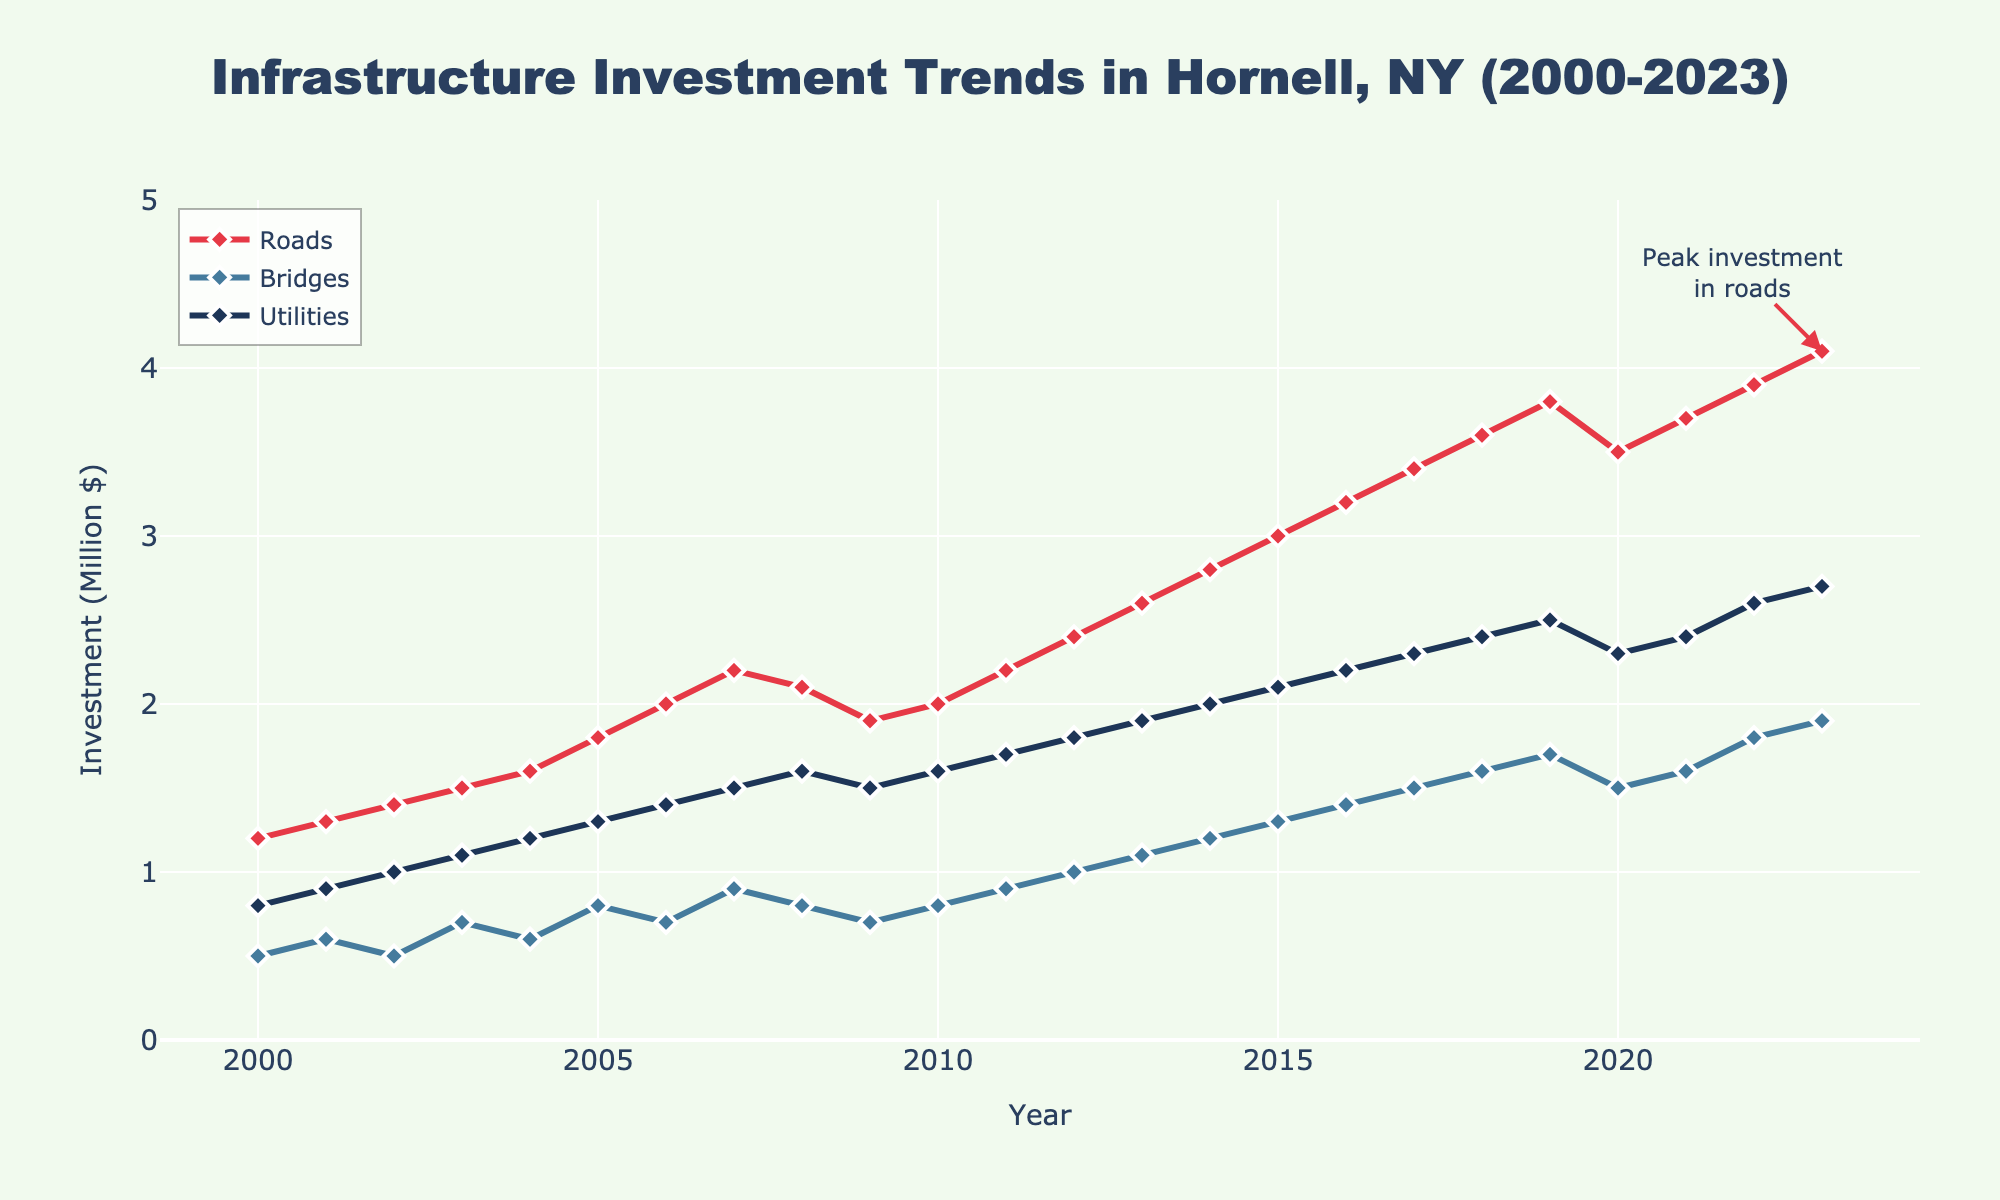What is the total investment in roads and bridges for the year 2023? To find the total investment in roads and bridges for 2023, you sum the investment values for roads (4.1 million) and bridges (1.9 million). The sum is 4.1 + 1.9 = 6.0.
Answer: 6.0 million Which project type saw the highest peak investment over the given period? To determine which project type had the highest peak investment, look at the maximum values for each type: Roads (4.1 million), Bridges (1.9 million), and Utilities (2.7 million). The highest value is 4.1 million for Roads.
Answer: Roads What was the average investment in utilities from 2000 to 2010? Calculate the average by summing the utilities investments from 2000 to 2010 and dividing by the number of years. Sum = 0.8 + 0.9 + 1.0 + 1.1 + 1.2 + 1.3 + 1.4 + 1.5 + 1.6 + 1.5 = 11.3. There are 11 years, so the average is 11.3 / 11.
Answer: 1.027 million How did the investment in bridges change from 2010 to 2015? Compare the values in 2010 (0.8 million) and 2015 (1.3 million). The change is 1.3 - 0.8 = 0.5 million. The investment increased by 0.5 million.
Answer: Increased by 0.5 million In which year did investment in utilities first reach 2 million dollars? Identify the first year in which the investment in utilities reached 2.0 million by observing the data. This occurred in 2014.
Answer: 2014 By how much did the investment in roads increase from 2000 to 2023? Calculate the difference in roads investment between 2023 (4.1 million) and 2000 (1.2 million). The increase is 4.1 - 1.2 = 2.9 million.
Answer: 2.9 million Which two project types had the closest investment values in 2020, and what was the difference? Compare the investments in 2020: Roads (3.5 million), Bridges (1.5 million), and Utilities (2.3 million). Bridges and Utilities are closest with a difference of 2.3 - 1.5 = 0.8 million.
Answer: Bridges and Utilities, 0.8 million What is the overall trend in investment for utilities from 2000 to 2023? Review the pattern of utilities investments: starting at 0.8 million in 2000 and ending at 2.7 million in 2023, showing a consistent increase over the years.
Answer: Increasing In which year did road investments experience a decrease compared to the previous year? Identify the years where road investments decreased relative to the prior year by examining the values year-by-year. The decrease occurred in 2020 compared to 2019 (3.8 to 3.5 million).
Answer: 2020 Which investment type had the most fluctuations, and how can you tell? Look at the relative ups and downs in the investment trends of roads, bridges, and utilities. Bridges show the most fluctuation with several increases and decreases over the years.
Answer: Bridges 